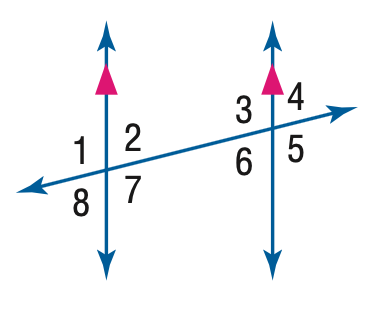Question: In the figure, m \angle 1 = 94. Find the measure of \angle 5.
Choices:
A. 76
B. 86
C. 94
D. 96
Answer with the letter. Answer: C 